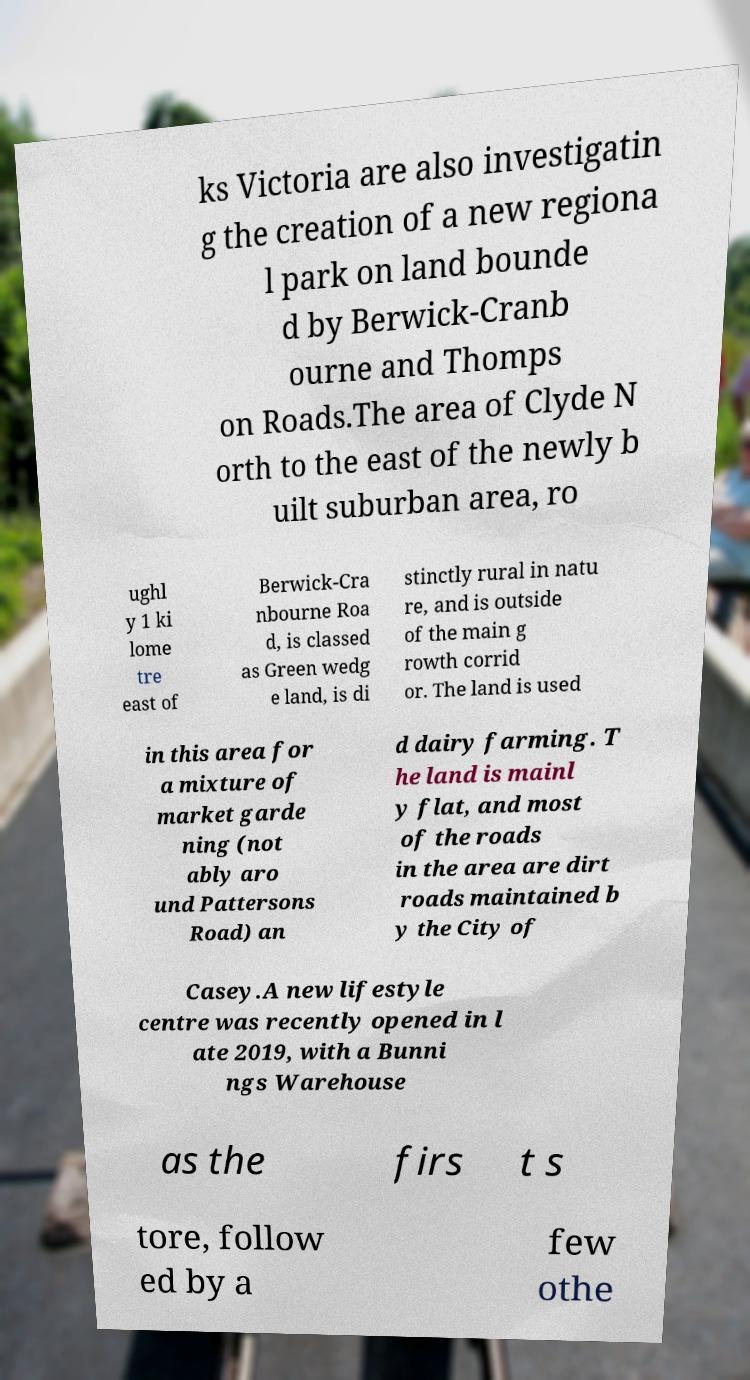Please read and relay the text visible in this image. What does it say? ks Victoria are also investigatin g the creation of a new regiona l park on land bounde d by Berwick-Cranb ourne and Thomps on Roads.The area of Clyde N orth to the east of the newly b uilt suburban area, ro ughl y 1 ki lome tre east of Berwick-Cra nbourne Roa d, is classed as Green wedg e land, is di stinctly rural in natu re, and is outside of the main g rowth corrid or. The land is used in this area for a mixture of market garde ning (not ably aro und Pattersons Road) an d dairy farming. T he land is mainl y flat, and most of the roads in the area are dirt roads maintained b y the City of Casey.A new lifestyle centre was recently opened in l ate 2019, with a Bunni ngs Warehouse as the firs t s tore, follow ed by a few othe 